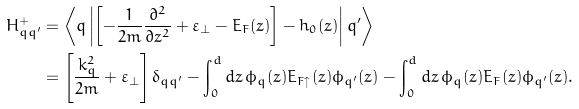Convert formula to latex. <formula><loc_0><loc_0><loc_500><loc_500>H ^ { + } _ { q q ^ { \prime } } & = \left \langle q \left | \left [ - \frac { 1 } { 2 m } \frac { \partial ^ { 2 } } { \partial z ^ { 2 } } + \varepsilon _ { \perp } - E _ { F } ( z ) \right ] - h _ { 0 } ( z ) \right | q ^ { \prime } \right \rangle \, \\ & = \left [ \frac { k ^ { 2 } _ { q } } { 2 m } + \varepsilon _ { \perp } \right ] \delta _ { q q ^ { \prime } } - \int _ { 0 } ^ { d } d z \, \phi _ { q } ( z ) E _ { F \uparrow } ( z ) \phi _ { q ^ { \prime } } ( z ) - \int _ { 0 } ^ { d } d z \, \phi _ { q } ( z ) E _ { F } ( z ) \phi _ { q ^ { \prime } } ( z ) .</formula> 